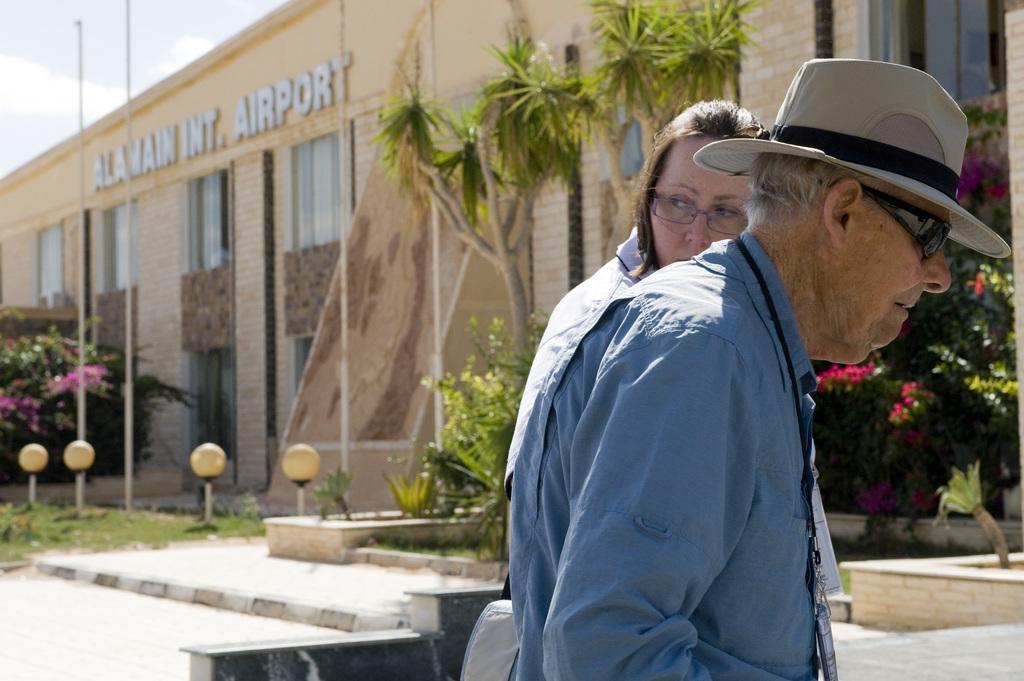How would you summarize this image in a sentence or two? In this image I can see two persons. In the background I can see plants, trees, light poles and a building. On the top left I can see the sky. This image is taken near the airport station. 